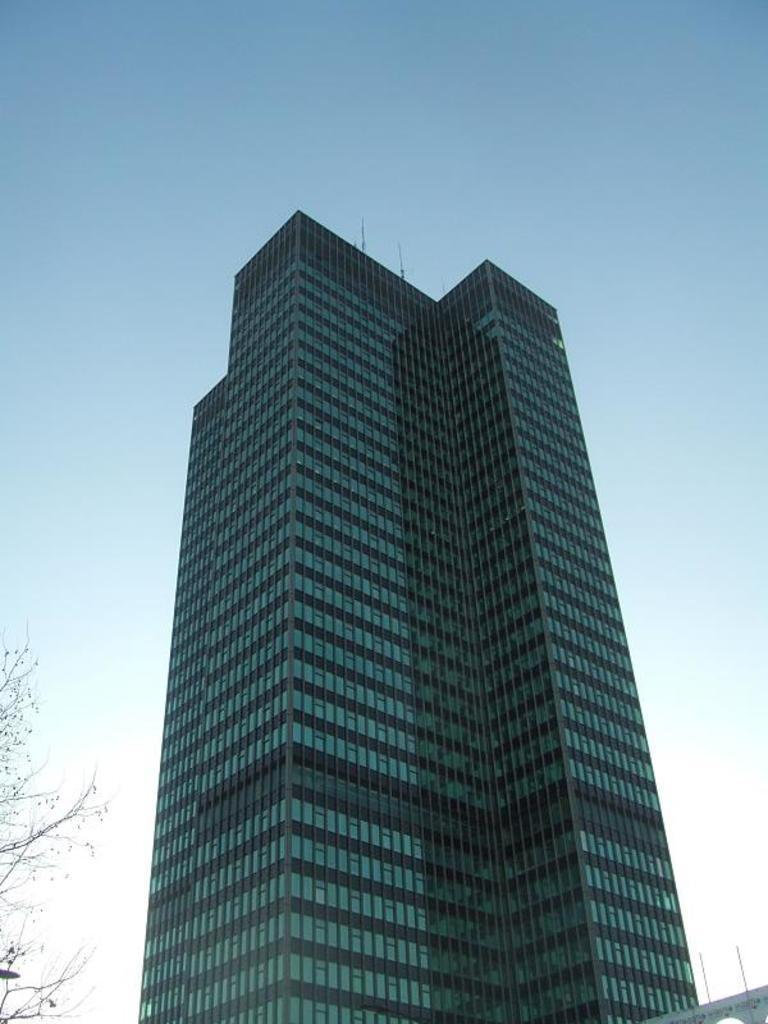What type of structure is present in the image? There is a building in the image. What natural element can be seen in the image? There is a tree in the image. What can be seen in the distance in the image? The sky is visible in the background of the image. What type of competition is taking place in the image? There is no competition present in the image. What relation does the tree have to the building in the image? The tree and the building are separate entities in the image, and no specific relation between them is mentioned or implied. 